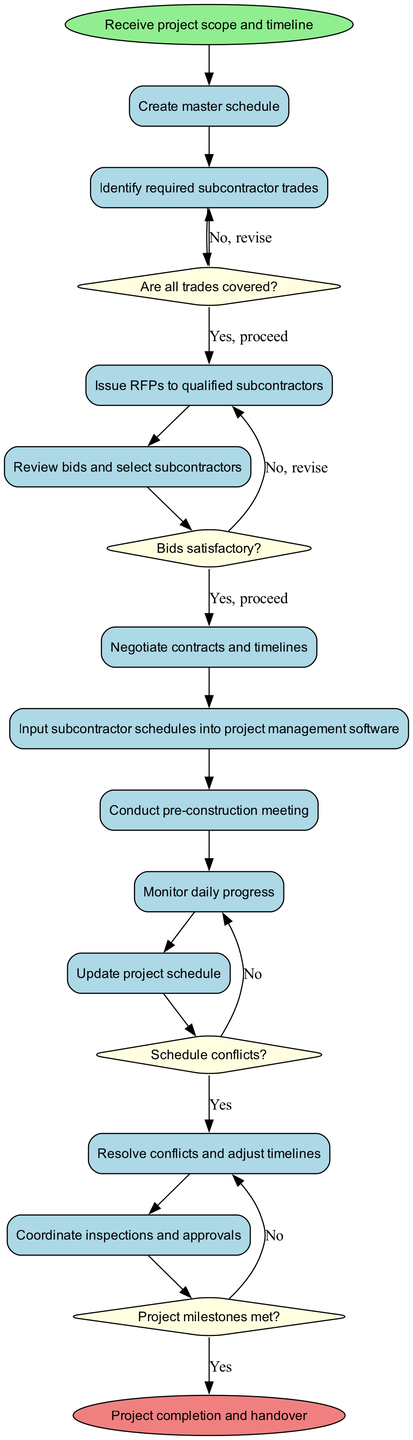What is the initial node of the diagram? The initial node is labeled "Receive project scope and timeline," representing the starting point of the workflow.
Answer: Receive project scope and timeline How many activities are there in total? The diagram lists 11 activities, which illustrate the steps in managing subcontractor assignments and schedules.
Answer: 11 What happens if the bids are satisfactory? If the bids are satisfactory, the flow proceeds from the respective decision node to the next activity, indicating that subcontractors will be selected and contracted.
Answer: Proceed to select subcontractors What decision comes after inputting subcontractor schedules? After inputting subcontractor schedules, there is a decision labeled "Schedule conflicts?" that determines if any overlaps or issues exist in the scheduling of subcontractors.
Answer: Schedule conflicts? What is the final node of the diagram? The final node, indicating the end of the workflow, is labeled "Project completion and handover," representing the successful conclusion of the building project.
Answer: Project completion and handover If the project milestones are not met, what corrective action is taken? If project milestones are not met, the workflow indicates to implement corrective actions, suggesting adjustments are needed to stay on track.
Answer: Implement corrective actions Which activity follows the pre-construction meeting? The activity that follows the pre-construction meeting is "Monitor daily progress," which is crucial for tracking the ongoing work of subcontractors.
Answer: Monitor daily progress How many decision nodes are present in the diagram? There are 4 decision nodes in the diagram, which help guide the workflow based on specific criteria like trade coverage and bid satisfaction.
Answer: 4 What occurs if not all trades are covered? If not all trades are covered, the diagram indicates to revise the master schedule until all needs are addressed, ensuring that all functionalities are fulfilled.
Answer: Revise master schedule 